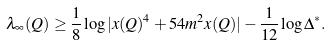<formula> <loc_0><loc_0><loc_500><loc_500>\lambda _ { \infty } ( Q ) \geq \frac { 1 } { 8 } \log | x ( Q ) ^ { 4 } + 5 4 m ^ { 2 } x ( Q ) | - \frac { 1 } { 1 2 } \log \Delta ^ { * } .</formula> 